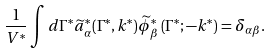Convert formula to latex. <formula><loc_0><loc_0><loc_500><loc_500>\frac { 1 } { V ^ { \ast } } \int d \Gamma ^ { \ast } \widetilde { a } _ { \alpha } ^ { \ast } ( \Gamma ^ { \ast } , k ^ { \ast } ) \widetilde { \phi } _ { \beta } ^ { \ast } \left ( \Gamma ^ { \ast } ; - k ^ { \ast } \right ) = \delta _ { \alpha \beta } .</formula> 